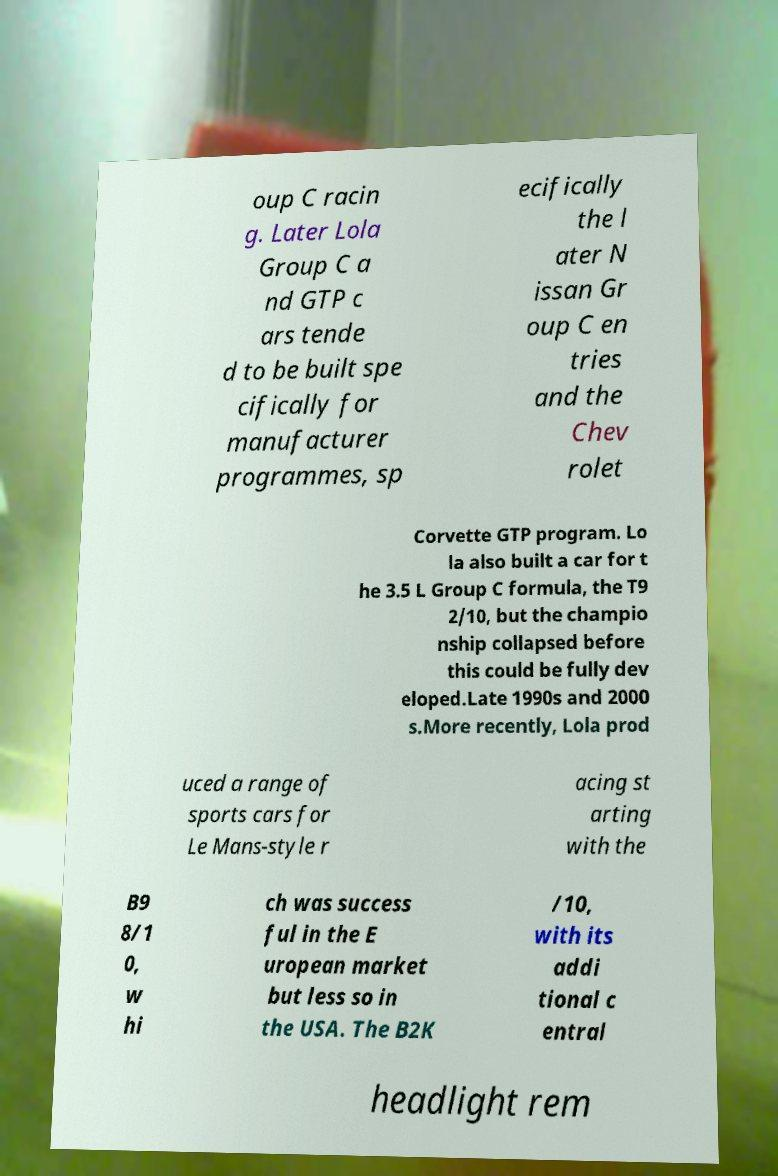Could you extract and type out the text from this image? oup C racin g. Later Lola Group C a nd GTP c ars tende d to be built spe cifically for manufacturer programmes, sp ecifically the l ater N issan Gr oup C en tries and the Chev rolet Corvette GTP program. Lo la also built a car for t he 3.5 L Group C formula, the T9 2/10, but the champio nship collapsed before this could be fully dev eloped.Late 1990s and 2000 s.More recently, Lola prod uced a range of sports cars for Le Mans-style r acing st arting with the B9 8/1 0, w hi ch was success ful in the E uropean market but less so in the USA. The B2K /10, with its addi tional c entral headlight rem 